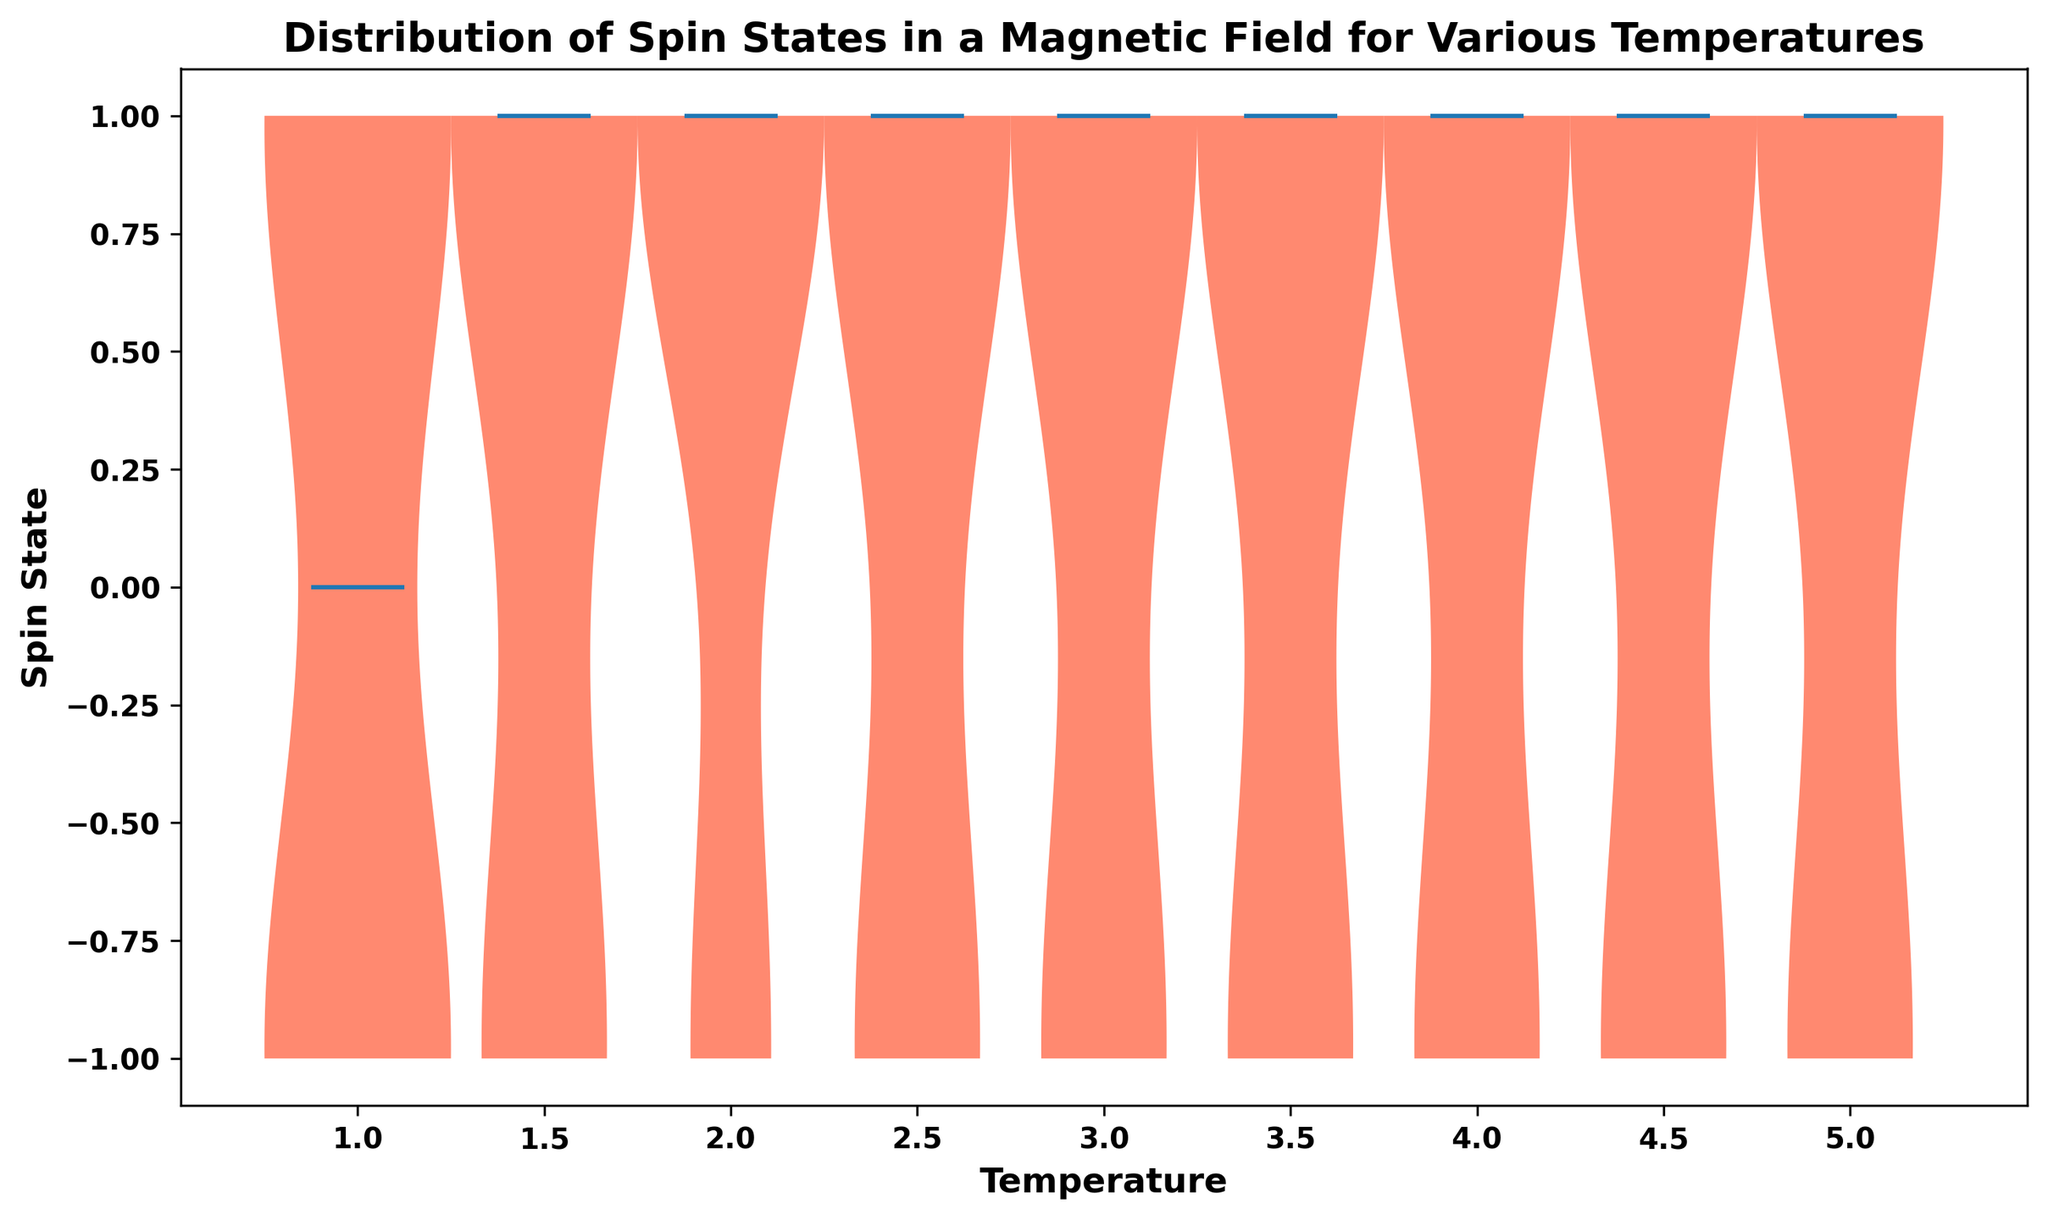What temperatures were used in the study? From the plot, we can observe the x-axis which lists all the unique temperatures used in the study.
Answer: 1.0, 1.5, 2.0, 2.5, 3.0, 3.5, 4.0, 4.5, 5.0 At which temperature is the distribution of spin states visually the widest? By observing the overall width of the violin plots at each temperature, we can determine which temperature has the widest distribution. The distribution appears widest around temperature 5.0.
Answer: 5.0 What is the overall trend of the median spin state as temperature increases? The median is represented by the white dot within each violin plot. By tracking these dots across increasing temperatures, the median shifts from being centered around -1 at lower temperatures to being centered around 1 at higher temperatures.
Answer: Increases towards 1 At what temperature do the spin states show the most variation? To determine this, we look for the violin plot with the largest spread from -1 to 1. The spread appears to be largest in both temperatures 1.0 and 5.0.
Answer: 1.0 and 5.0 Compare the median spin state at temperature 1.5 with that at 3.0. The white dot in the violin plot centered at 1.5 is significantly closer to 1, whereas at 3.0, it is still centered around 1 but with a slight shift. This suggests a transition phase.
Answer: Both centered around 1 but 1.5 is slightly higher How does the concentration of spin states at -1 change with temperature? By looking at the width of the violin plot at -1 across temperatures, we notice that at lower temperatures (e.g., 1.0), the concentration is higher, while at higher temperatures (e.g., 5.0), it decreases.
Answer: Decreases with increasing temperature If temperature is increased from 2.5 to 4.0, how does the median spin state change? Observing the white dots of the violin plots at temperatures 2.5 and 4.0, we see the median is centered around 1. Hence, the shift shows an upward trend towards the positive spin state as temperature increases.
Answer: Remains around 1 What temperature corresponds to a notable shift in spin state concentration from -1 to 1? By visually inspecting the violin plots for a drastic change, we notice the shift begins around 1.5 and continues until 3.0.
Answer: 3.0 How many different values does the Spin State variable take? The violin plots display only two values represented by peaks at -1 and 1.
Answer: 2 Are there any clusters of spin states observed at specific temperatures? The violin plots show that the distribution becomes more clustered around 1 as temperature increases, especially at temperatures above 3.0.
Answer: Yes, more at spin state 1 at higher temperatures 